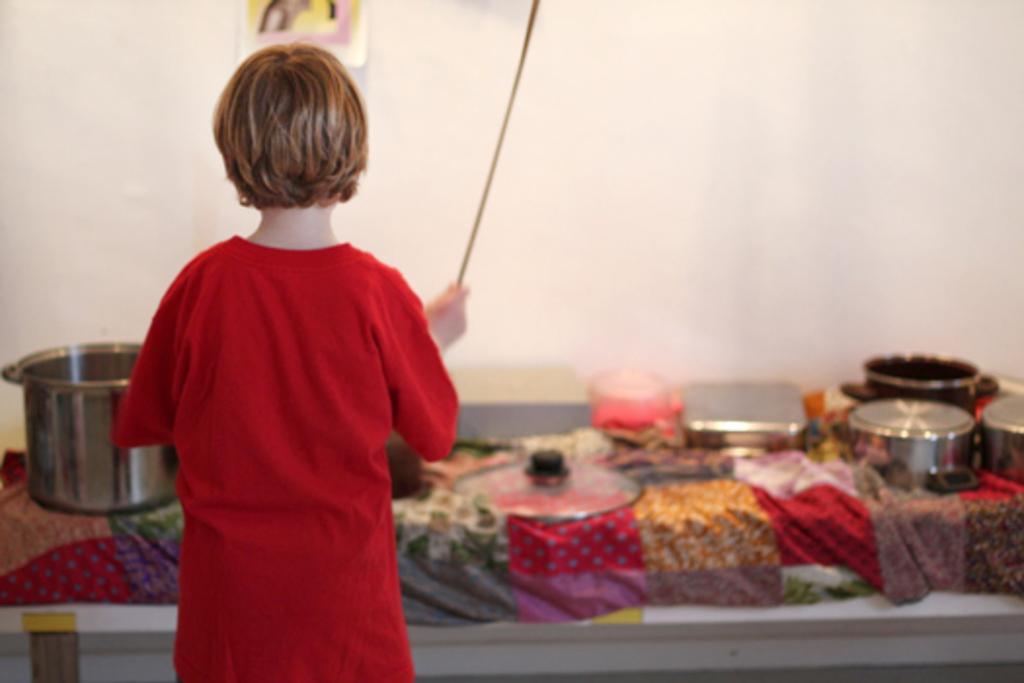How would you summarize this image in a sentence or two? In this picture I can see a person in front who is wearing red color t-shirt and holding a stick. In the background I can see a table on which there is colorful cloth and on the cloth I can see number of utensils and I can see the wall. 